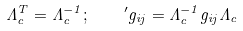Convert formula to latex. <formula><loc_0><loc_0><loc_500><loc_500>\Lambda _ { c } ^ { T } = \Lambda _ { c } ^ { - 1 } ; \quad ^ { \prime } g _ { i j } = \Lambda _ { c } ^ { - 1 } g _ { i j } \Lambda _ { c }</formula> 